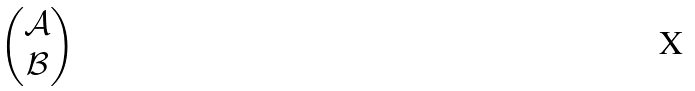<formula> <loc_0><loc_0><loc_500><loc_500>\begin{pmatrix} \mathcal { A } \\ \mathcal { B } \end{pmatrix}</formula> 